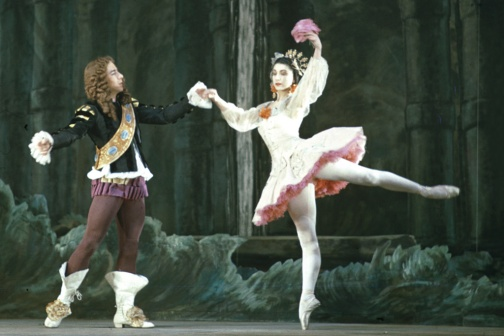Who do you think the characters in this ballet might be? Given the elaborate and regal costumes, the characters in this ballet could likely be portraying figures from a fairy tale or historical romance. The male dancer's attire suggests he might be a nobleman or prince, perhaps inviting his beloved or ward into a moment of dance. The female dancer, with her fairy-like tutu and ethereal pose, could be a princess, a spirit, or a muse. Their interaction hints at a romantic or dramatic storyline, central to many classic ballets. 